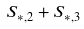Convert formula to latex. <formula><loc_0><loc_0><loc_500><loc_500>S _ { * , 2 } + S _ { * , 3 }</formula> 